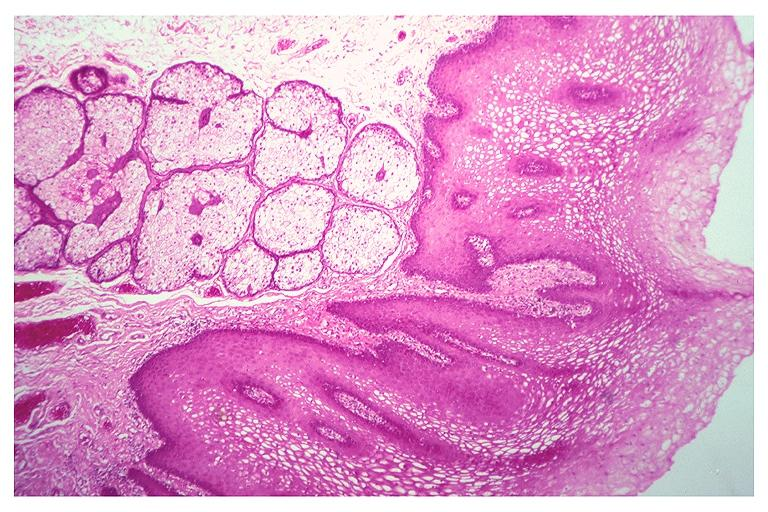what is present?
Answer the question using a single word or phrase. Oral 